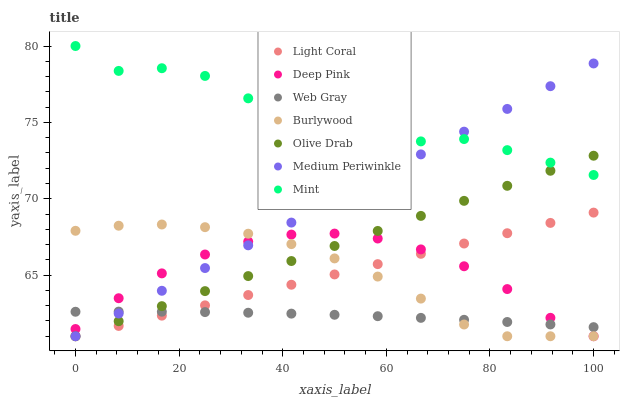Does Web Gray have the minimum area under the curve?
Answer yes or no. Yes. Does Mint have the maximum area under the curve?
Answer yes or no. Yes. Does Burlywood have the minimum area under the curve?
Answer yes or no. No. Does Burlywood have the maximum area under the curve?
Answer yes or no. No. Is Medium Periwinkle the smoothest?
Answer yes or no. Yes. Is Mint the roughest?
Answer yes or no. Yes. Is Burlywood the smoothest?
Answer yes or no. No. Is Burlywood the roughest?
Answer yes or no. No. Does Deep Pink have the lowest value?
Answer yes or no. Yes. Does Web Gray have the lowest value?
Answer yes or no. No. Does Mint have the highest value?
Answer yes or no. Yes. Does Burlywood have the highest value?
Answer yes or no. No. Is Light Coral less than Mint?
Answer yes or no. Yes. Is Mint greater than Burlywood?
Answer yes or no. Yes. Does Web Gray intersect Light Coral?
Answer yes or no. Yes. Is Web Gray less than Light Coral?
Answer yes or no. No. Is Web Gray greater than Light Coral?
Answer yes or no. No. Does Light Coral intersect Mint?
Answer yes or no. No. 